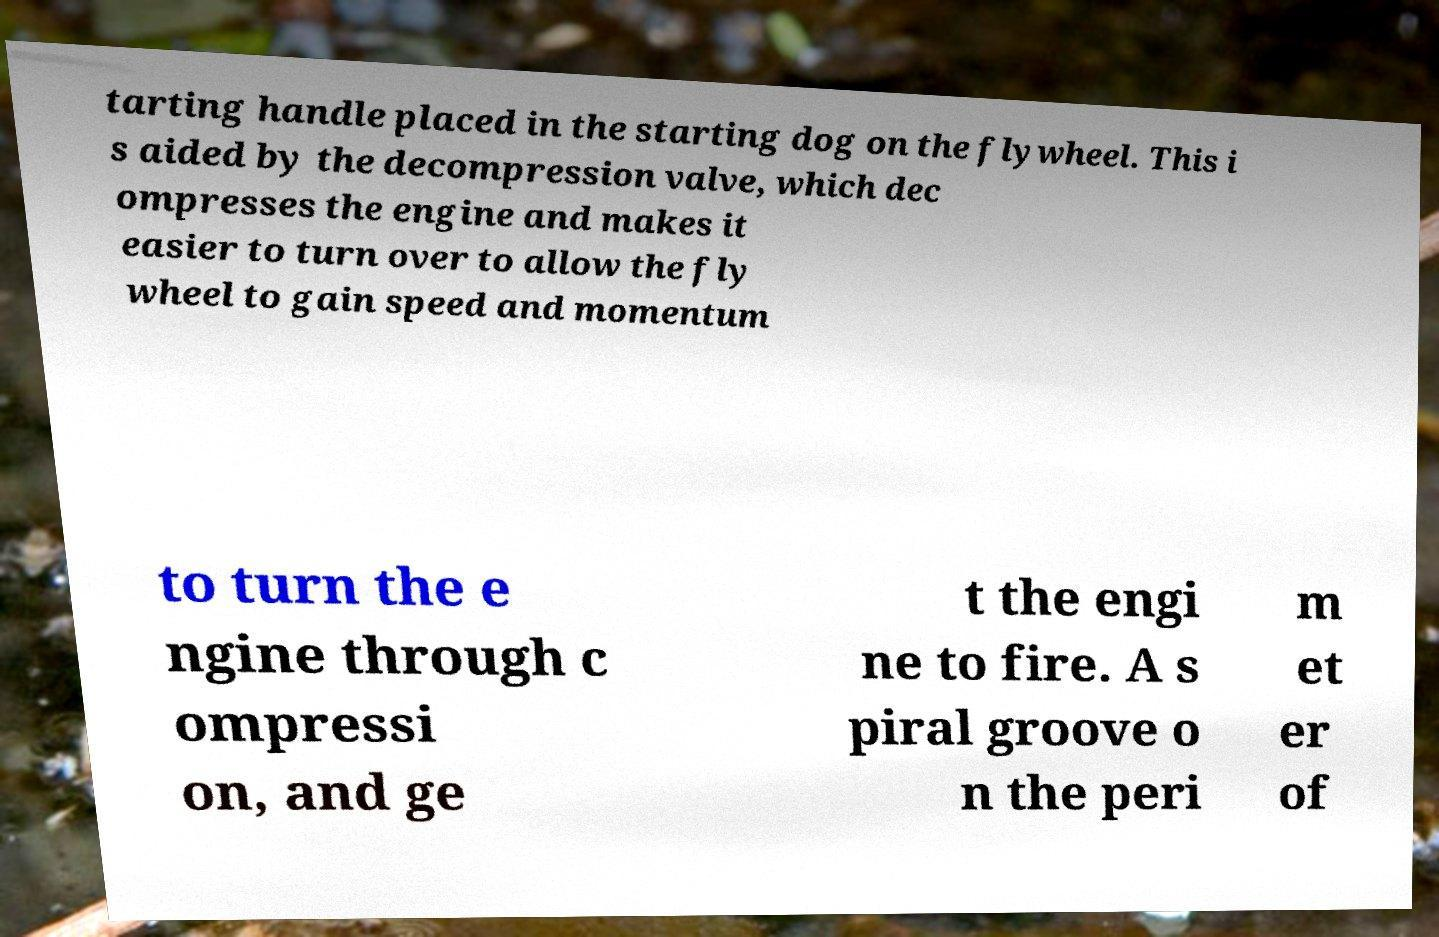I need the written content from this picture converted into text. Can you do that? tarting handle placed in the starting dog on the flywheel. This i s aided by the decompression valve, which dec ompresses the engine and makes it easier to turn over to allow the fly wheel to gain speed and momentum to turn the e ngine through c ompressi on, and ge t the engi ne to fire. A s piral groove o n the peri m et er of 